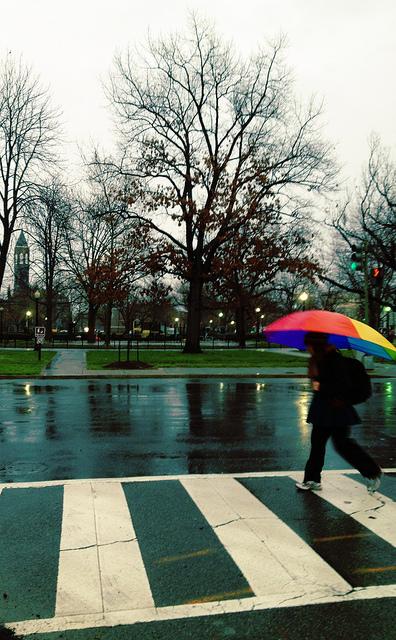Should this person be using an umbrella?
Quick response, please. Yes. How is the weather?
Be succinct. Rainy. What intersection is this crosswalk at?
Quick response, please. Pennsylvania. 